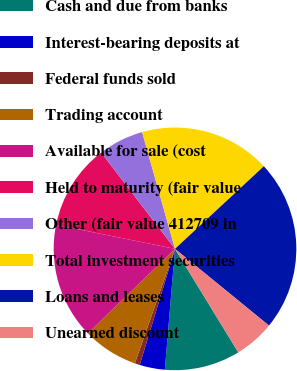Convert chart to OTSL. <chart><loc_0><loc_0><loc_500><loc_500><pie_chart><fcel>Cash and due from banks<fcel>Interest-bearing deposits at<fcel>Federal funds sold<fcel>Trading account<fcel>Available for sale (cost<fcel>Held to maturity (fair value<fcel>Other (fair value 412709 in<fcel>Total investment securities<fcel>Loans and leases<fcel>Unearned discount<nl><fcel>10.07%<fcel>3.36%<fcel>0.67%<fcel>7.38%<fcel>15.44%<fcel>11.41%<fcel>6.04%<fcel>17.45%<fcel>22.82%<fcel>5.37%<nl></chart> 